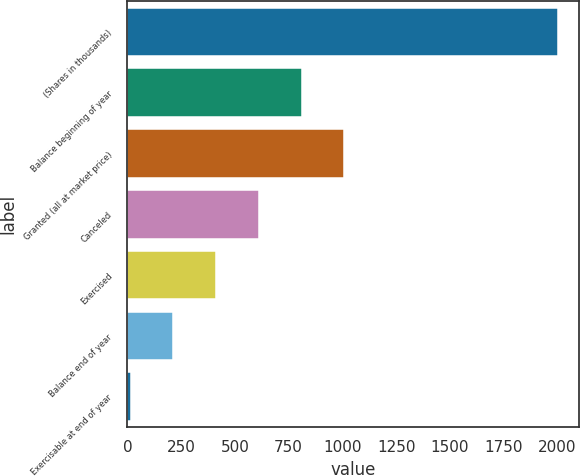Convert chart. <chart><loc_0><loc_0><loc_500><loc_500><bar_chart><fcel>(Shares in thousands)<fcel>Balance beginning of year<fcel>Granted (all at market price)<fcel>Canceled<fcel>Exercised<fcel>Balance end of year<fcel>Exercisable at end of year<nl><fcel>2001<fcel>809.78<fcel>1008.31<fcel>611.25<fcel>412.72<fcel>214.19<fcel>15.66<nl></chart> 